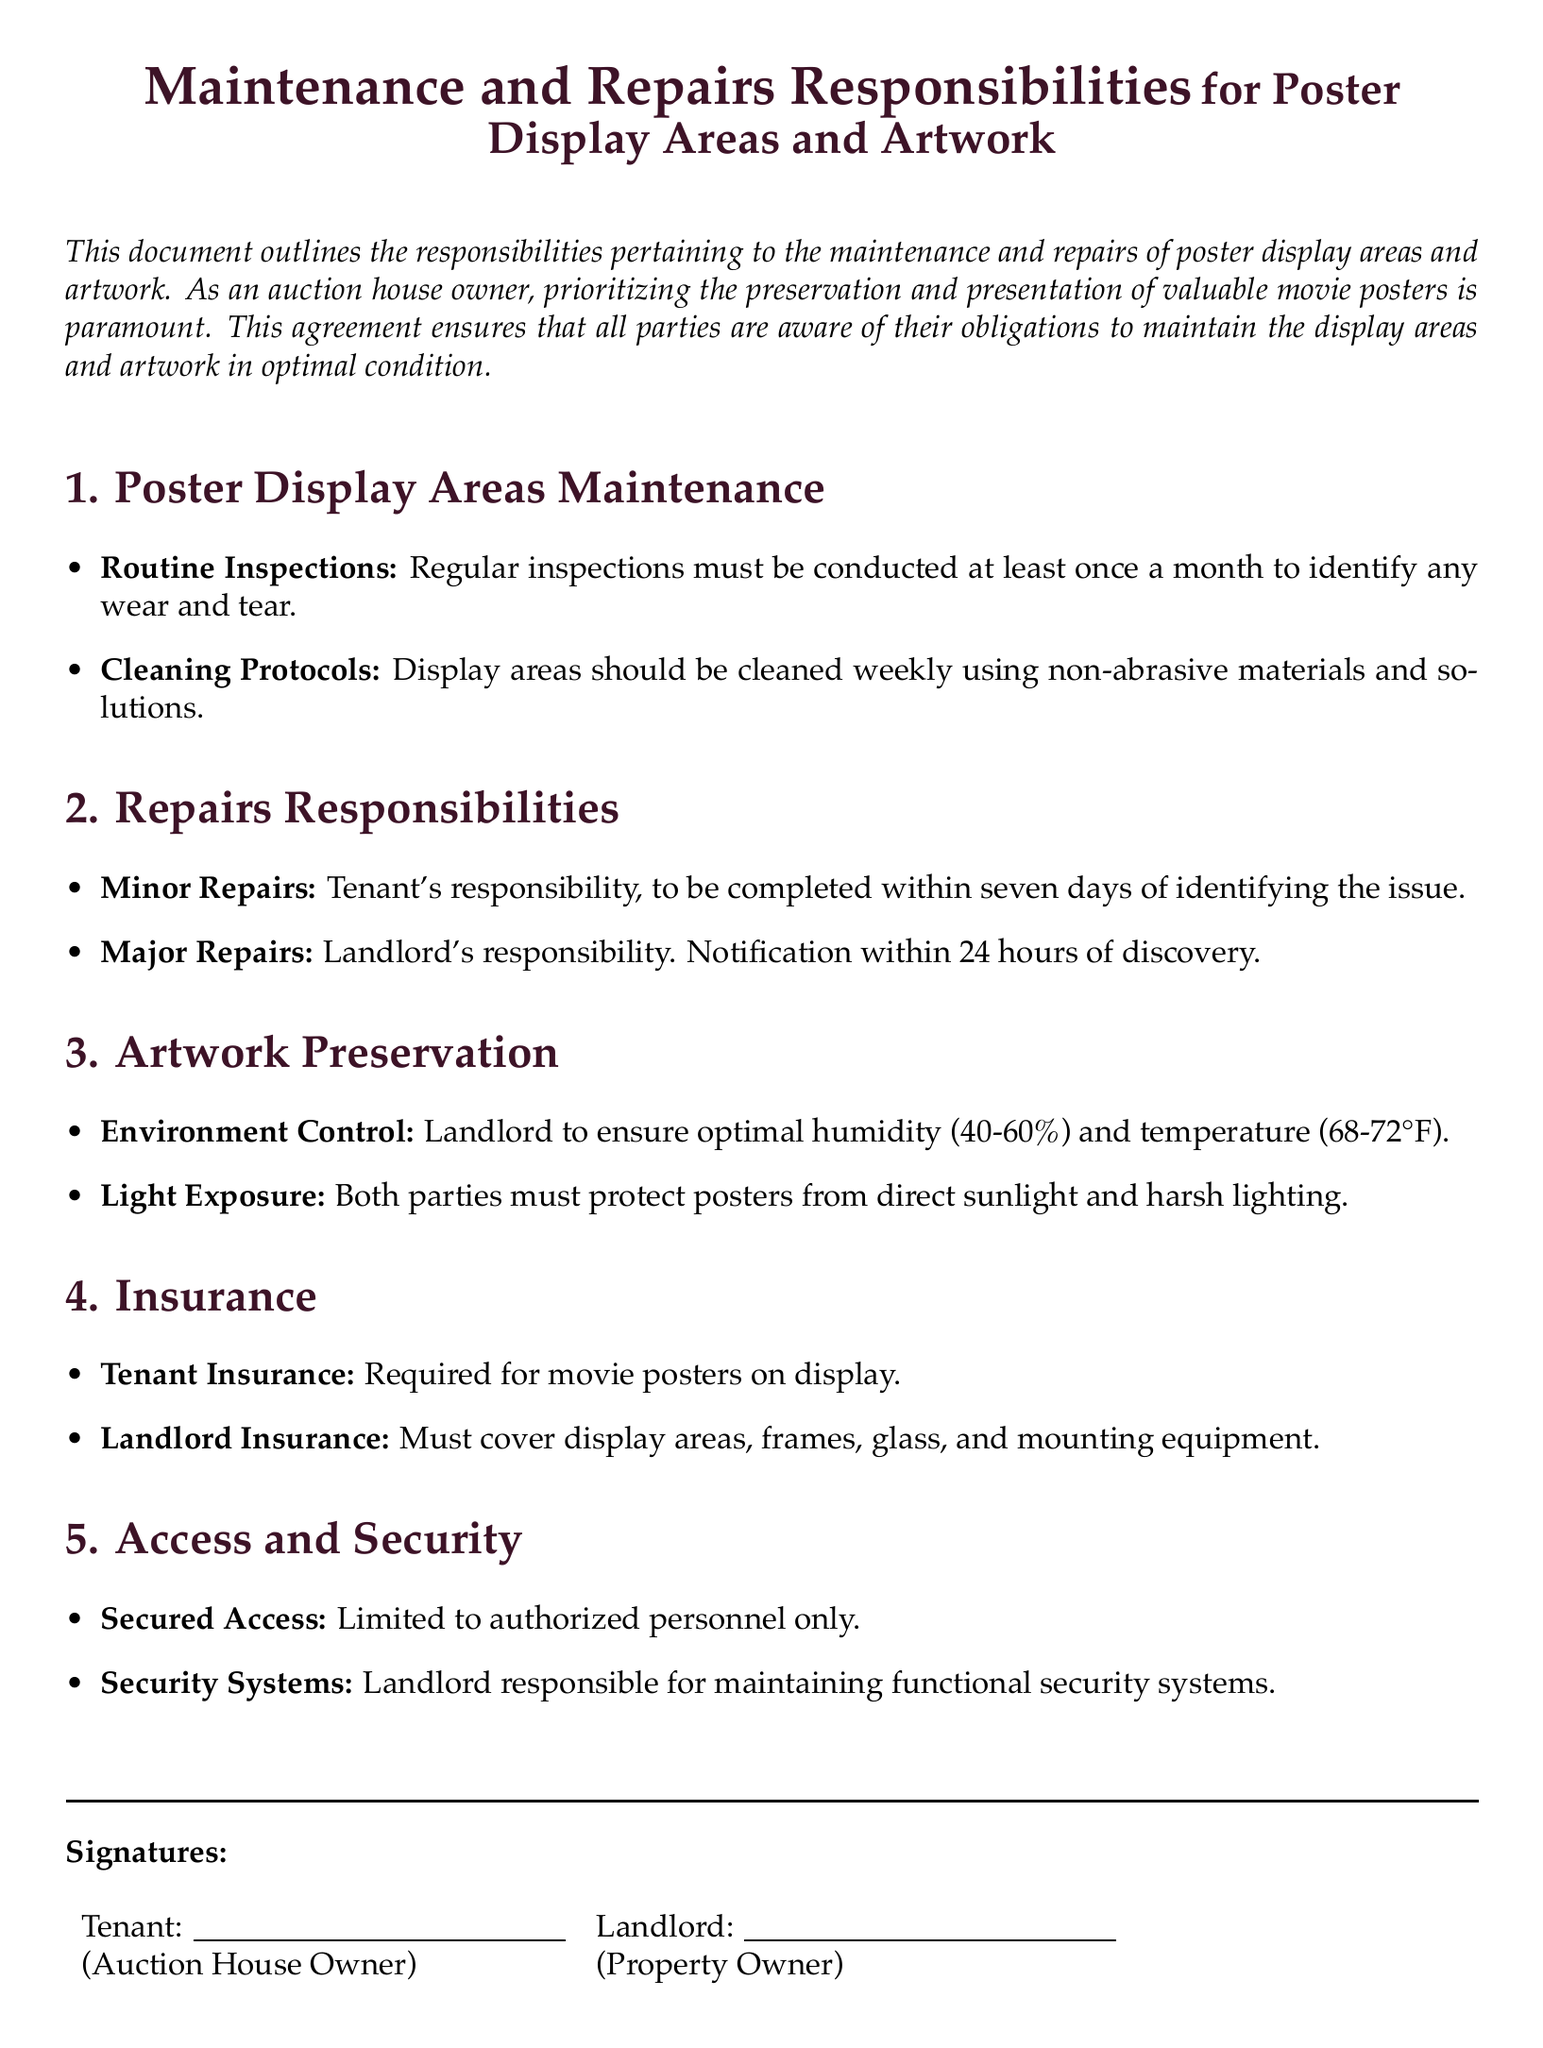what is the frequency of routine inspections? The document specifies that regular inspections must be conducted at least once a month.
Answer: once a month who is responsible for minor repairs? The responsibility for minor repairs lies with the tenant.
Answer: tenant what is the optimal humidity range for artwork preservation? The optimal humidity range for artwork preservation is explicitly specified in the document.
Answer: 40-60% what must be protected from direct sunlight? Both parties must protect posters from direct sunlight and harsh lighting, as stated in the document.
Answer: posters how quickly must minor repairs be completed? The document states that minor repairs must be completed within seven days of identifying the issue.
Answer: seven days who is responsible for maintaining security systems? The landlord is responsible for maintaining functional security systems as specified in the document.
Answer: landlord what type of insurance is required for movie posters? The document mandates that tenant insurance is required for movie posters on display.
Answer: tenant insurance what is the landlord's responsibility regarding major repairs? The landlord must be notified within 24 hours of discovery for major repairs, according to the document.
Answer: notify within 24 hours how often should display areas be cleaned? The document indicates that display areas should be cleaned weekly.
Answer: weekly 